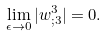<formula> <loc_0><loc_0><loc_500><loc_500>\lim _ { \epsilon \rightarrow 0 } | w ^ { 3 } _ { ; 3 } | = 0 .</formula> 